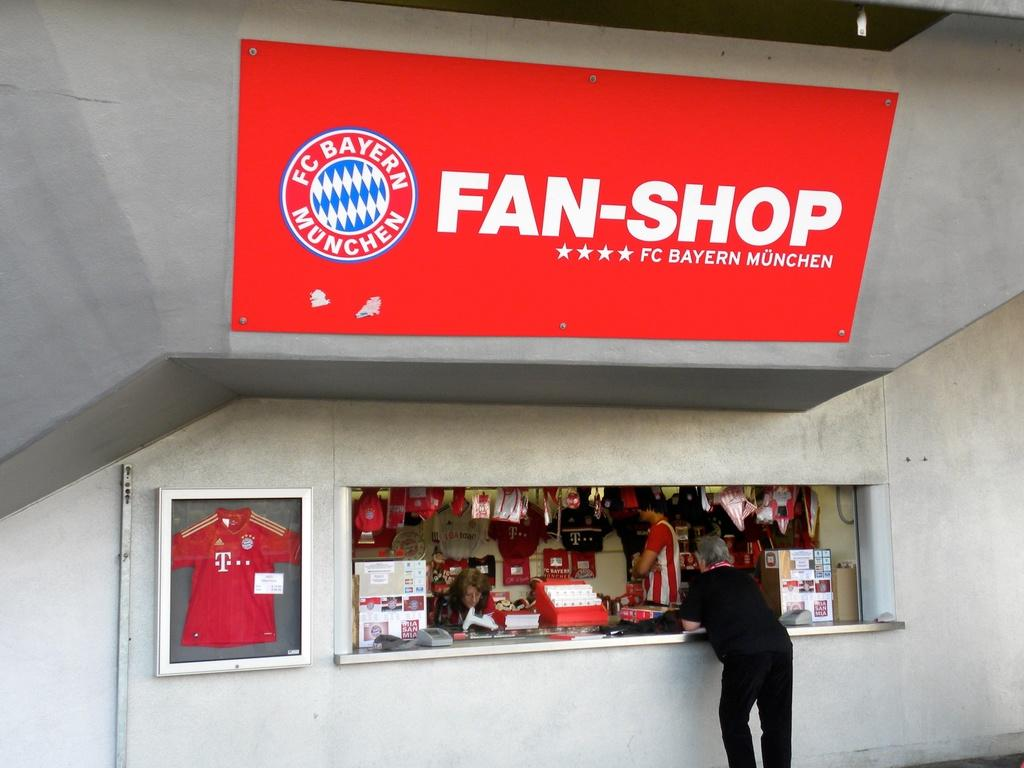Provide a one-sentence caption for the provided image. The Fan shop of the FC Bayern Munchen team. 